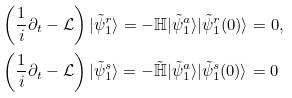Convert formula to latex. <formula><loc_0><loc_0><loc_500><loc_500>& \left ( \frac { 1 } { i } \partial _ { t } - \mathcal { L } \right ) | \tilde { \psi } _ { 1 } ^ { r } \rangle = - \mathbb { H } | \tilde { \psi } _ { 1 } ^ { a } \rangle | \tilde { \psi } _ { 1 } ^ { r } ( 0 ) \rangle = 0 , \\ & \left ( \frac { 1 } { i } \partial _ { t } - \mathcal { L } \right ) | \tilde { \psi } _ { 1 } ^ { s } \rangle = - \tilde { \mathbb { H } } | \tilde { \psi } _ { 1 } ^ { a } \rangle | \tilde { \psi } _ { 1 } ^ { s } ( 0 ) \rangle = 0</formula> 